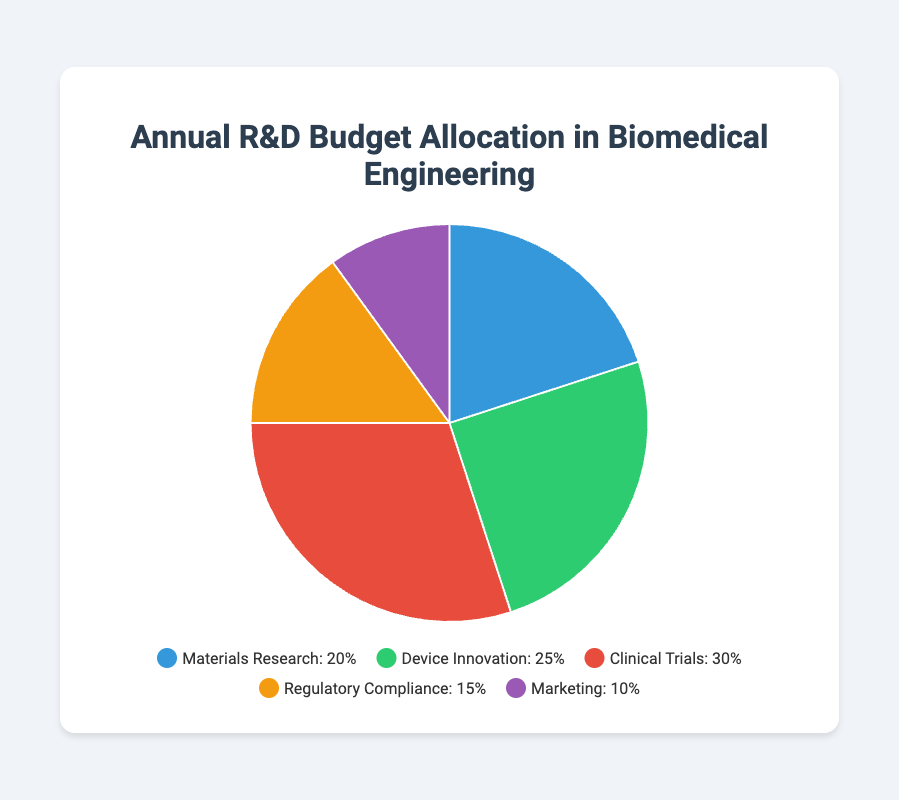What category has the highest allocation percentage? Clinical Trials has the highest allocation at 30%, as shown in the larger segment of the pie chart compared to others.
Answer: Clinical Trials Which category has the lowest allocation percentage? Marketing has the lowest allocation at 10%, as indicated by the smallest segment in the pie chart.
Answer: Marketing What is the total percentage allocation for Materials Research and Device Innovation combined? Add the percentages for Materials Research (20%) and Device Innovation (25%) to get 20% + 25% = 45%.
Answer: 45% How much higher is the allocation for Clinical Trials compared to Regulatory Compliance? Subtract the allocation of Regulatory Compliance (15%) from Clinical Trials (30%) to get 30% - 15% = 15%.
Answer: 15% Which category is allocated less than Device Innovation but more than Marketing? Regulatory Compliance is allocated 15%, which is less than Device Innovation (25%) but more than Marketing (10%).
Answer: Regulatory Compliance What is the average allocation percentage for all categories? Sum all the allocation percentages: 20% (Materials Research) + 25% (Device Innovation) + 30% (Clinical Trials) + 15% (Regulatory Compliance) + 10% (Marketing) = 100%. Divide by 5 to get the average: 100% / 5 = 20%.
Answer: 20% Is the allocation for Regulatory Compliance higher or lower than the combined allocation for Marketing and Materials Research? Combined allocation for Marketing (10%) and Materials Research (20%) is 10% + 20% = 30%. Regulatory Compliance allocation is 15%, which is lower than 30%.
Answer: Lower What is the percentage difference between the highest and lowest allocated categories? The highest allocation is for Clinical Trials at 30% and the lowest for Marketing at 10%. The percentage difference is 30% - 10% = 20%.
Answer: 20% Which category is represented by the purple segment in the pie chart? The purple segment represents Marketing, which has a 10% allocation.
Answer: Marketing If the allocation for Device Innovation were increased by 5%, what would be its new allocation percentage? Increase Device Innovation allocation (25%) by 5% to get 25% + 5% = 30%.
Answer: 30% 